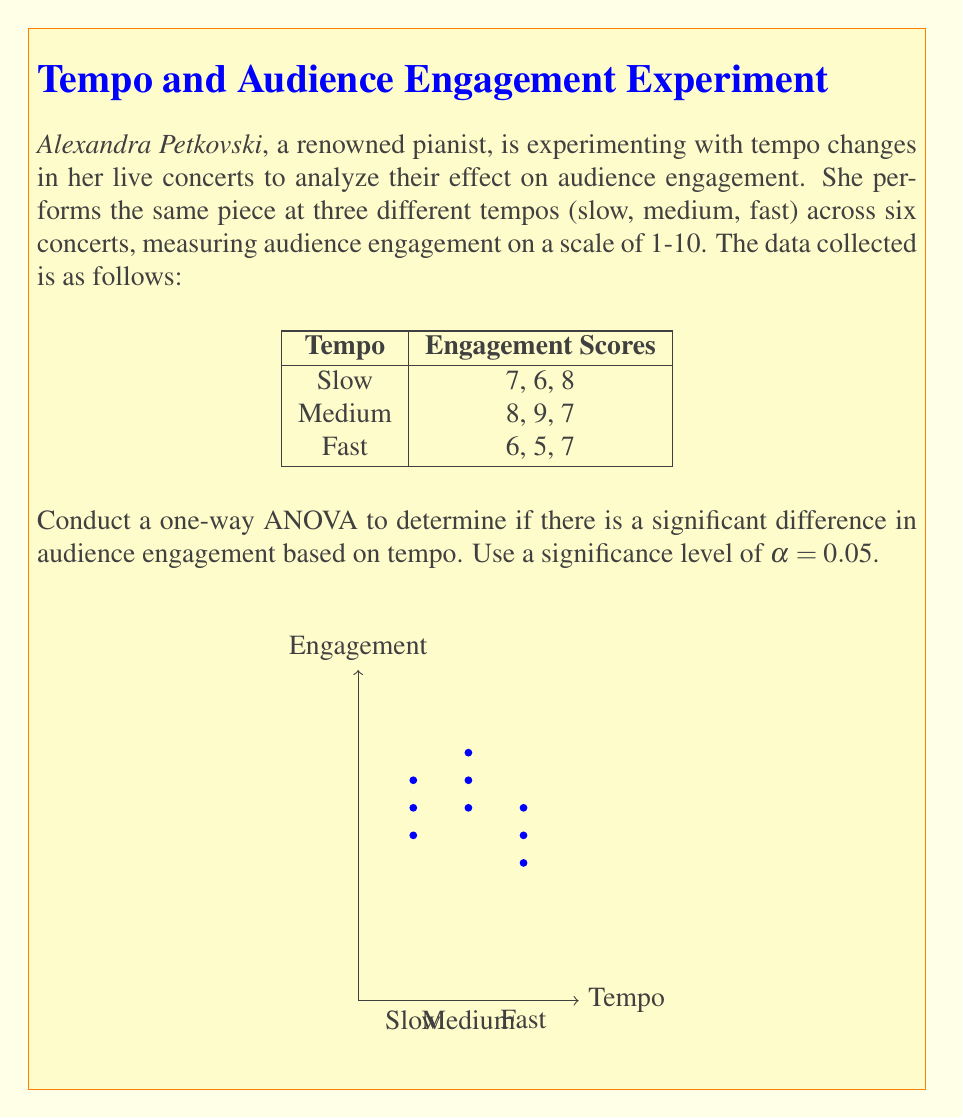Solve this math problem. Let's perform a one-way ANOVA step-by-step:

1. Calculate the total sum of squares (SST):
   $$SST = \sum_{i=1}^{n} (x_i - \bar{x})^2$$
   where $\bar{x}$ is the grand mean.
   
   Grand mean = $\frac{7+6+8+8+9+7+6+5+7}{9} = 7$
   
   $$SST = (7-7)^2 + (6-7)^2 + ... + (7-7)^2 = 14$$

2. Calculate the sum of squares between groups (SSB):
   $$SSB = \sum_{i=1}^{k} n_i(\bar{x}_i - \bar{x})^2$$
   where $k$ is the number of groups, $n_i$ is the size of each group, and $\bar{x}_i$ is the mean of each group.
   
   $$SSB = 3((7-7)^2 + (8-7)^2 + (6-7)^2) = 6$$

3. Calculate the sum of squares within groups (SSW):
   $$SSW = SST - SSB = 14 - 6 = 8$$

4. Calculate degrees of freedom:
   - Between groups: $df_B = k - 1 = 3 - 1 = 2$
   - Within groups: $df_W = N - k = 9 - 3 = 6$
   - Total: $df_T = N - 1 = 9 - 1 = 8$

5. Calculate mean squares:
   $$MS_B = \frac{SSB}{df_B} = \frac{6}{2} = 3$$
   $$MS_W = \frac{SSW}{df_W} = \frac{8}{6} = 1.33$$

6. Calculate F-statistic:
   $$F = \frac{MS_B}{MS_W} = \frac{3}{1.33} = 2.25$$

7. Find the critical F-value:
   For α = 0.05, $df_B = 2$, and $df_W = 6$, the critical F-value is approximately 5.14.

8. Compare F-statistic to critical F-value:
   Since 2.25 < 5.14, we fail to reject the null hypothesis.
Answer: F(2,6) = 2.25, p > 0.05. No significant difference in audience engagement based on tempo. 